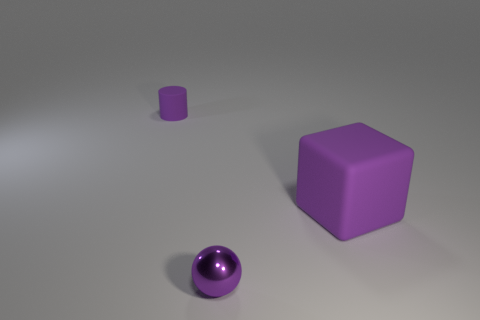Add 1 tiny red metallic cylinders. How many objects exist? 4 Subtract all spheres. How many objects are left? 2 Subtract all tiny rubber things. Subtract all tiny cylinders. How many objects are left? 1 Add 2 spheres. How many spheres are left? 3 Add 1 yellow balls. How many yellow balls exist? 1 Subtract 0 gray blocks. How many objects are left? 3 